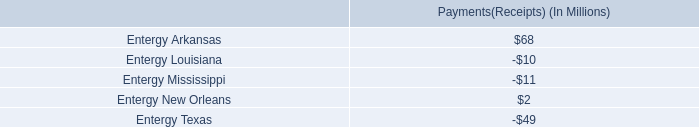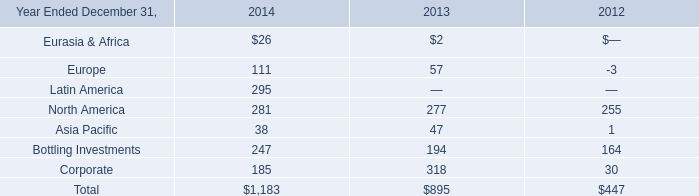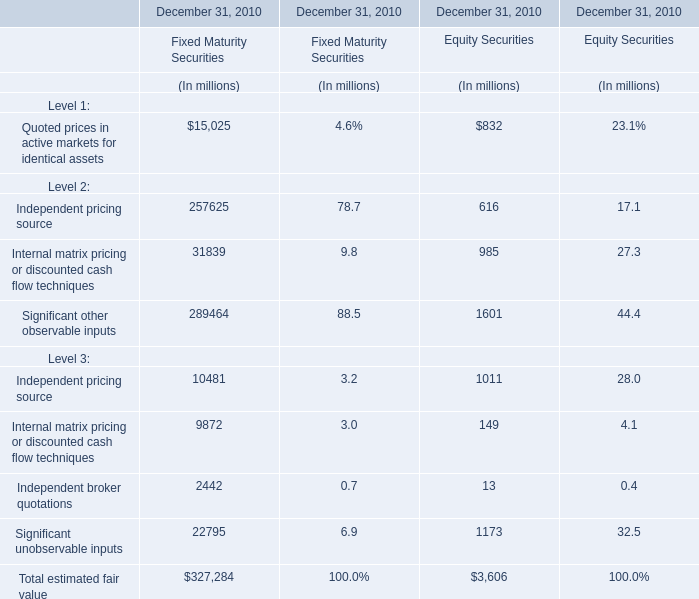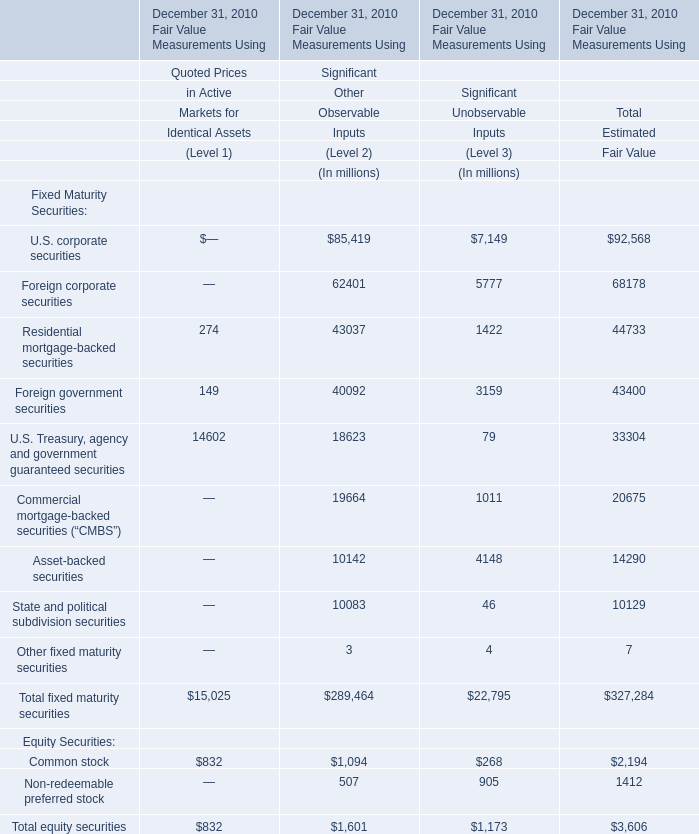Which Level is Independent pricing source for Fixed Maturity Securities in terms of rate at December 31, 2010 more between Level 2 and Level 3 ? 
Answer: 2. 